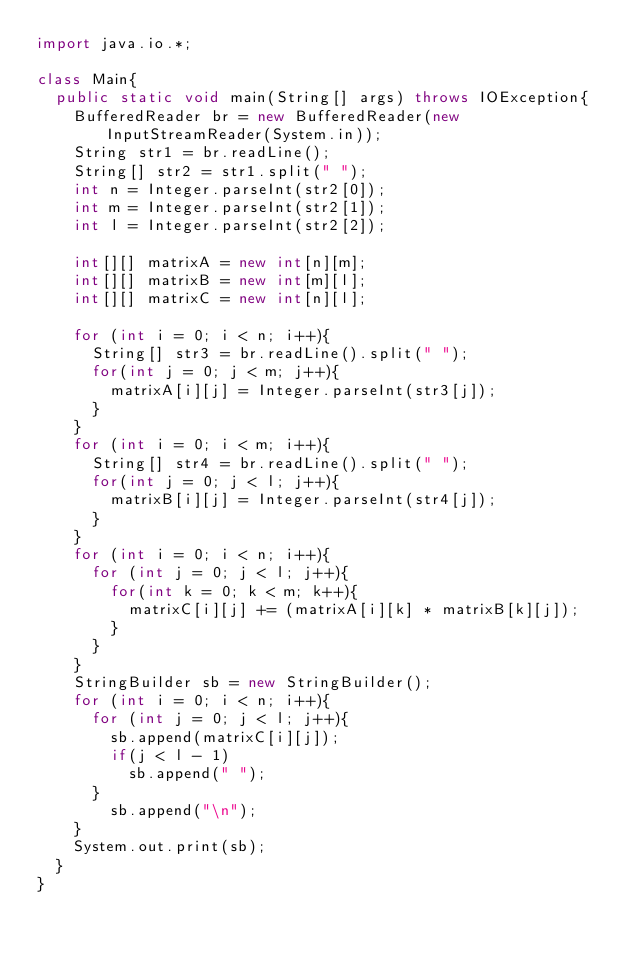Convert code to text. <code><loc_0><loc_0><loc_500><loc_500><_Java_>import java.io.*;

class Main{
  public static void main(String[] args) throws IOException{
    BufferedReader br = new BufferedReader(new InputStreamReader(System.in));
    String str1 = br.readLine();
    String[] str2 = str1.split(" ");
    int n = Integer.parseInt(str2[0]);
    int m = Integer.parseInt(str2[1]);
    int l = Integer.parseInt(str2[2]);

    int[][] matrixA = new int[n][m];
    int[][] matrixB = new int[m][l];
    int[][] matrixC = new int[n][l];

    for (int i = 0; i < n; i++){
      String[] str3 = br.readLine().split(" ");
      for(int j = 0; j < m; j++){
        matrixA[i][j] = Integer.parseInt(str3[j]);
      }
    }
    for (int i = 0; i < m; i++){
      String[] str4 = br.readLine().split(" ");
      for(int j = 0; j < l; j++){
        matrixB[i][j] = Integer.parseInt(str4[j]);
      }
    }
    for (int i = 0; i < n; i++){
      for (int j = 0; j < l; j++){
        for(int k = 0; k < m; k++){
          matrixC[i][j] += (matrixA[i][k] * matrixB[k][j]);
        }
      }
    }
    StringBuilder sb = new StringBuilder();
    for (int i = 0; i < n; i++){
      for (int j = 0; j < l; j++){
        sb.append(matrixC[i][j]);
        if(j < l - 1)
          sb.append(" ");
      }
        sb.append("\n");
    }
    System.out.print(sb);
  }
}</code> 